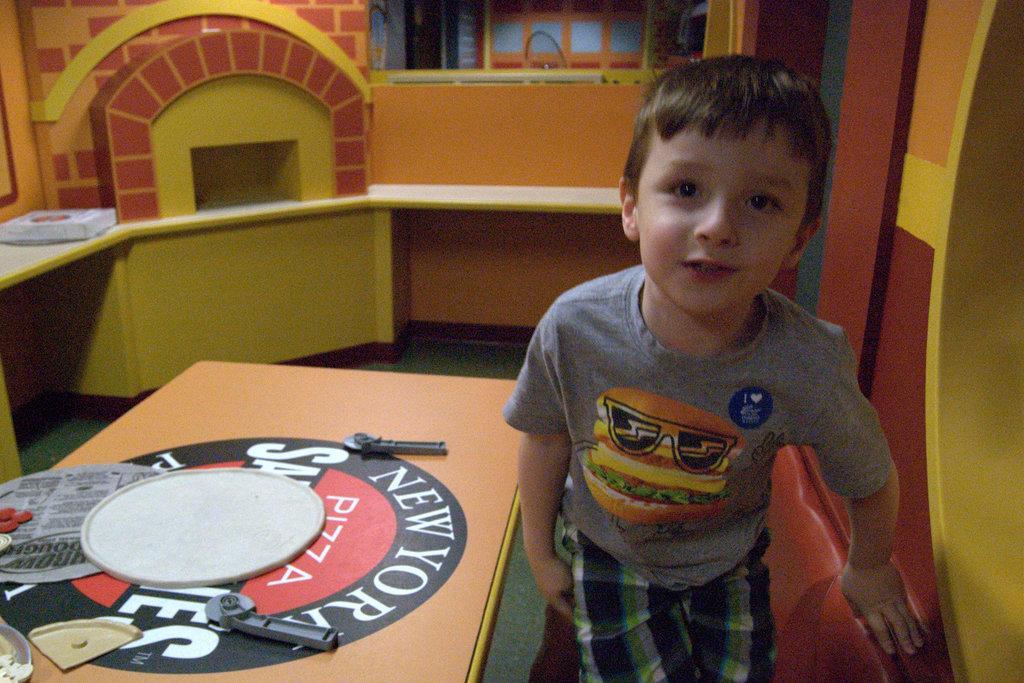Could you give a brief overview of what you see in this image? In this image I can see a boy standing on the right side of the image posing for the picture. I can see a table beside him with some objects on the table. I can see a pizza on a platform towards the left of a wooden construction at the top of the image. 